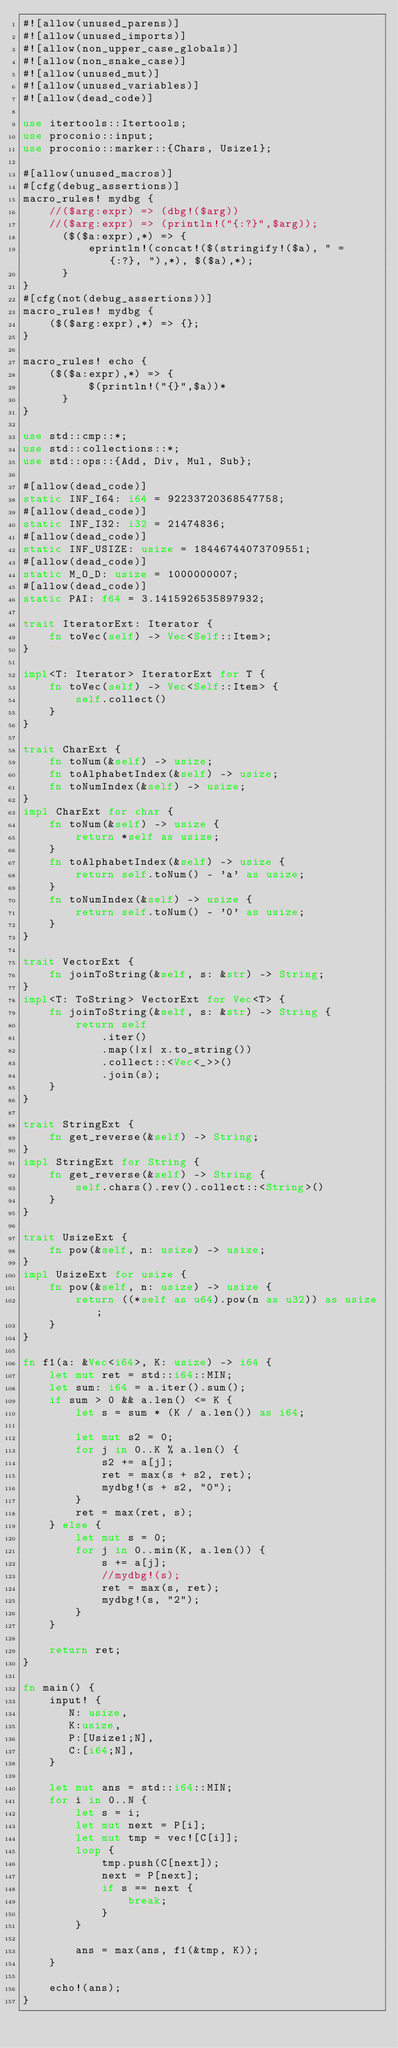Convert code to text. <code><loc_0><loc_0><loc_500><loc_500><_Rust_>#![allow(unused_parens)]
#![allow(unused_imports)]
#![allow(non_upper_case_globals)]
#![allow(non_snake_case)]
#![allow(unused_mut)]
#![allow(unused_variables)]
#![allow(dead_code)]

use itertools::Itertools;
use proconio::input;
use proconio::marker::{Chars, Usize1};

#[allow(unused_macros)]
#[cfg(debug_assertions)]
macro_rules! mydbg {
    //($arg:expr) => (dbg!($arg))
    //($arg:expr) => (println!("{:?}",$arg));
      ($($a:expr),*) => {
          eprintln!(concat!($(stringify!($a), " = {:?}, "),*), $($a),*);
      }
}
#[cfg(not(debug_assertions))]
macro_rules! mydbg {
    ($($arg:expr),*) => {};
}

macro_rules! echo {
    ($($a:expr),*) => {
          $(println!("{}",$a))*
      }
}

use std::cmp::*;
use std::collections::*;
use std::ops::{Add, Div, Mul, Sub};

#[allow(dead_code)]
static INF_I64: i64 = 92233720368547758;
#[allow(dead_code)]
static INF_I32: i32 = 21474836;
#[allow(dead_code)]
static INF_USIZE: usize = 18446744073709551;
#[allow(dead_code)]
static M_O_D: usize = 1000000007;
#[allow(dead_code)]
static PAI: f64 = 3.1415926535897932;

trait IteratorExt: Iterator {
    fn toVec(self) -> Vec<Self::Item>;
}

impl<T: Iterator> IteratorExt for T {
    fn toVec(self) -> Vec<Self::Item> {
        self.collect()
    }
}

trait CharExt {
    fn toNum(&self) -> usize;
    fn toAlphabetIndex(&self) -> usize;
    fn toNumIndex(&self) -> usize;
}
impl CharExt for char {
    fn toNum(&self) -> usize {
        return *self as usize;
    }
    fn toAlphabetIndex(&self) -> usize {
        return self.toNum() - 'a' as usize;
    }
    fn toNumIndex(&self) -> usize {
        return self.toNum() - '0' as usize;
    }
}

trait VectorExt {
    fn joinToString(&self, s: &str) -> String;
}
impl<T: ToString> VectorExt for Vec<T> {
    fn joinToString(&self, s: &str) -> String {
        return self
            .iter()
            .map(|x| x.to_string())
            .collect::<Vec<_>>()
            .join(s);
    }
}

trait StringExt {
    fn get_reverse(&self) -> String;
}
impl StringExt for String {
    fn get_reverse(&self) -> String {
        self.chars().rev().collect::<String>()
    }
}

trait UsizeExt {
    fn pow(&self, n: usize) -> usize;
}
impl UsizeExt for usize {
    fn pow(&self, n: usize) -> usize {
        return ((*self as u64).pow(n as u32)) as usize;
    }
}

fn f1(a: &Vec<i64>, K: usize) -> i64 {
    let mut ret = std::i64::MIN;
    let sum: i64 = a.iter().sum();
    if sum > 0 && a.len() <= K {
        let s = sum * (K / a.len()) as i64;

        let mut s2 = 0;
        for j in 0..K % a.len() {
            s2 += a[j];
            ret = max(s + s2, ret);
            mydbg!(s + s2, "0");
        }
        ret = max(ret, s);
    } else {
        let mut s = 0;
        for j in 0..min(K, a.len()) {
            s += a[j];
            //mydbg!(s);
            ret = max(s, ret);
            mydbg!(s, "2");
        }
    }

    return ret;
}

fn main() {
    input! {
       N: usize,
       K:usize,
       P:[Usize1;N],
       C:[i64;N],
    }

    let mut ans = std::i64::MIN;
    for i in 0..N {
        let s = i;
        let mut next = P[i];
        let mut tmp = vec![C[i]];
        loop {
            tmp.push(C[next]);
            next = P[next];
            if s == next {
                break;
            }
        }

        ans = max(ans, f1(&tmp, K));
    }

    echo!(ans);
}
</code> 